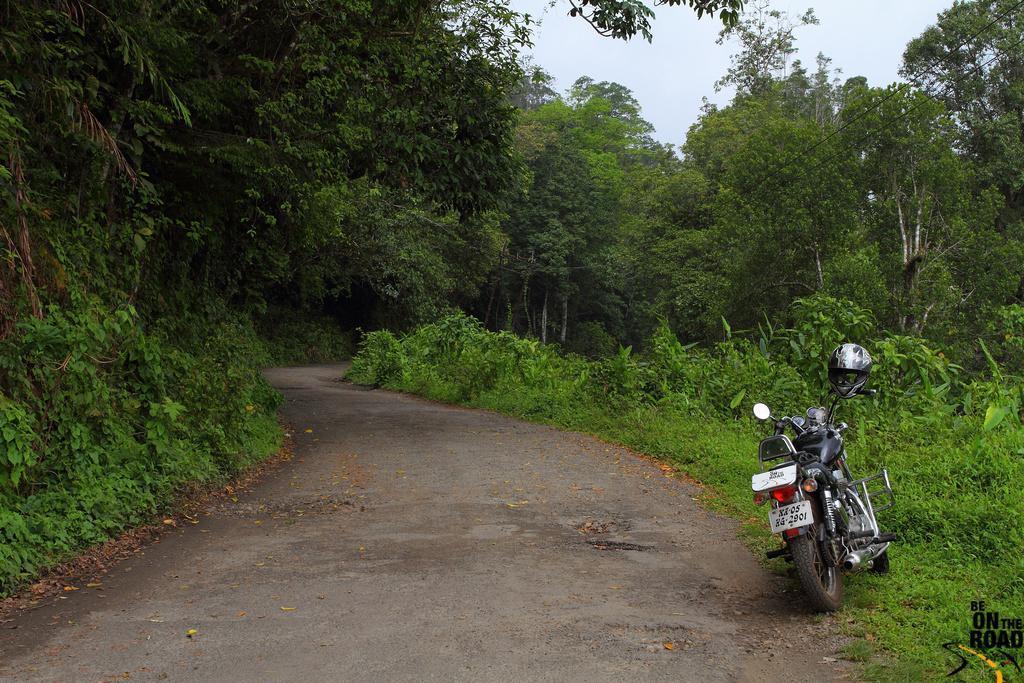How would you summarize this image in a sentence or two? In this picture we can see a bike, grass, road, plants, and trees. In the background there is sky. At the bottom of the picture we can see a watermark. 